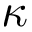<formula> <loc_0><loc_0><loc_500><loc_500>\kappa</formula> 